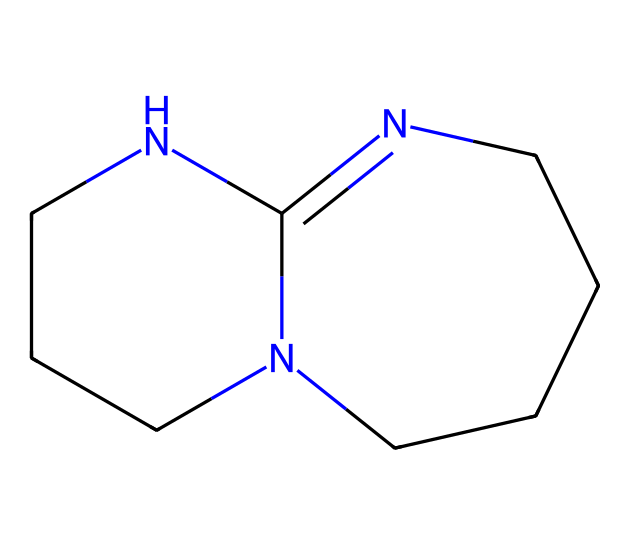What is the IUPAC name of this compound? The SMILES representation indicates the structure includes a bicyclic arrangement with nitrogen atoms. By analyzing the structure, the name of the compound can be determined as 1,5,7-triazabicyclo[4.4.0]dec-5-ene.
Answer: 1,5,7-triazabicyclo[4.4.0]dec-5-ene How many nitrogen atoms are present in this chemical? The structure contains three nitrogen atoms as indicated by the presence of 'N' in the SMILES.
Answer: three What is the total number of carbon atoms in this compound? By analyzing the SMILES representation and counting all 'C' characters present, it's determined that there are 10 carbon atoms in total.
Answer: ten What type of chemical is TBD classified as? Known for its strong basic properties, this compound fits the category of superbases due to the nitrogen atoms in a bicyclic structure that enhances electron donation.
Answer: superbase Which ring system is present in this chemical structure? The structure features a bicyclic ring system characterized by two interconnected rings, specifically reflecting a bicyclo[4.4.0] arrangement.
Answer: bicyclo[4.4.0] What is the primary functional group affecting its basicity? The basicity in this compound arises mainly from the presence of nitrogen atoms, which act as electron donors, making the amine functional groups primary in determining basicity.
Answer: amine 